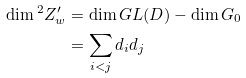<formula> <loc_0><loc_0><loc_500><loc_500>\dim { ^ { 2 } } Z _ { w } ^ { \prime } & = \dim G L ( D ) - \dim G _ { 0 } \\ & = \sum _ { i < j } d _ { i } d _ { j }</formula> 